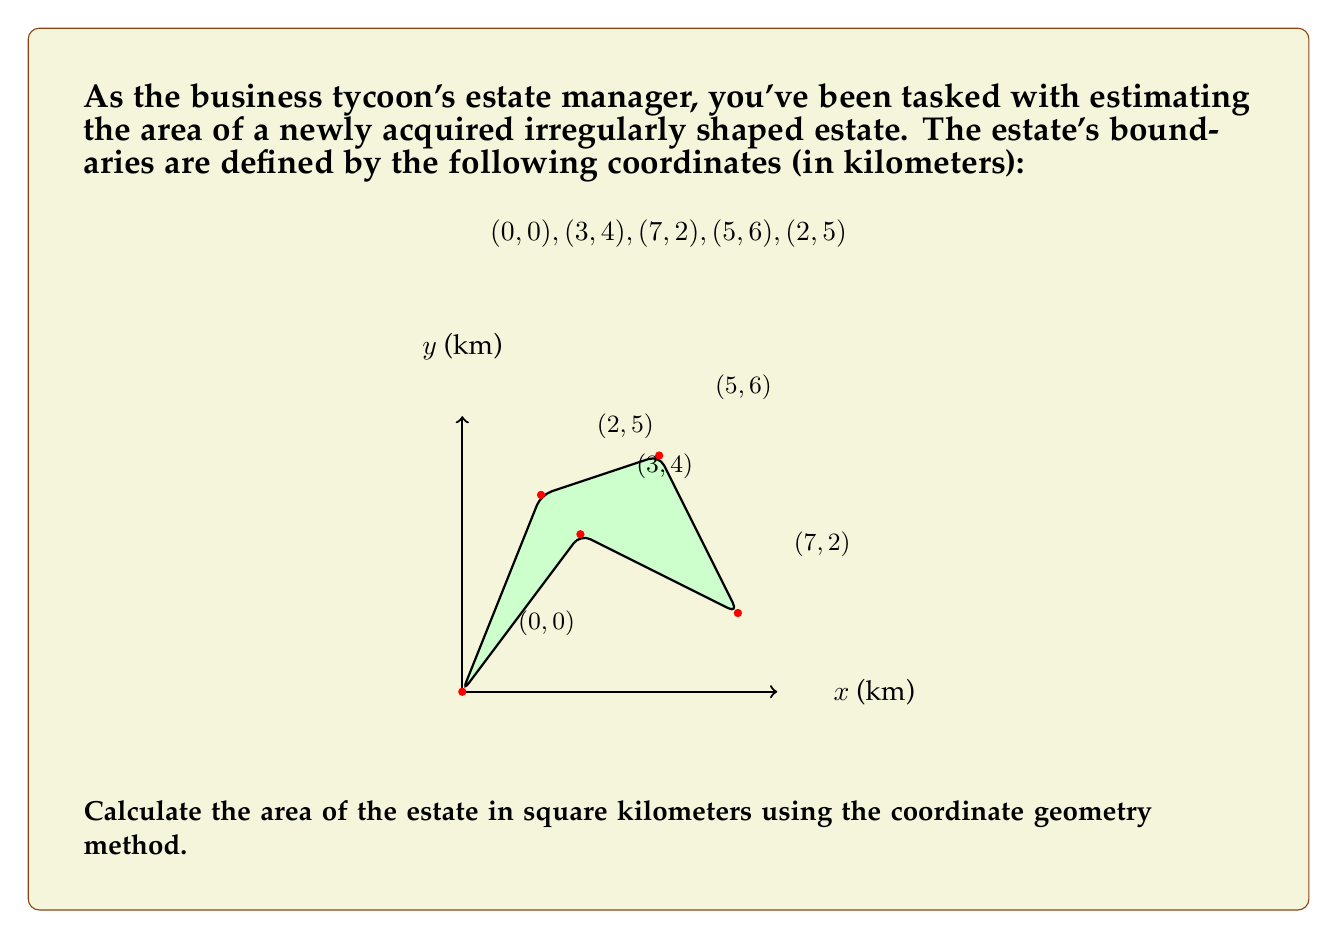Help me with this question. To calculate the area of this irregularly shaped estate, we can use the Shoelace formula (also known as the surveyor's formula). This method works for any polygon given its vertices.

The formula is:

$$A = \frac{1}{2}|\sum_{i=1}^{n-1} (x_i y_{i+1} + x_n y_1) - \sum_{i=1}^{n-1} (y_i x_{i+1} + y_n x_1)|$$

Where $(x_i, y_i)$ are the coordinates of the $i$-th vertex.

Let's apply this formula to our estate:

1) First, let's organize our points:
   $(x_1, y_1) = (0, 0)$
   $(x_2, y_2) = (3, 4)$
   $(x_3, y_3) = (7, 2)$
   $(x_4, y_4) = (5, 6)$
   $(x_5, y_5) = (2, 5)$

2) Now, let's calculate the first sum:
   $\sum_{i=1}^{n-1} (x_i y_{i+1} + x_n y_1)$
   $= (0 \cdot 4 + 3 \cdot 2 + 7 \cdot 6 + 5 \cdot 5 + 2 \cdot 0)$
   $= 0 + 6 + 42 + 25 + 0 = 73$

3) Next, calculate the second sum:
   $\sum_{i=1}^{n-1} (y_i x_{i+1} + y_n x_1)$
   $= (0 \cdot 3 + 4 \cdot 7 + 2 \cdot 5 + 6 \cdot 2 + 5 \cdot 0)$
   $= 0 + 28 + 10 + 12 + 0 = 50$

4) Subtract the second sum from the first:
   $73 - 50 = 23$

5) Take the absolute value and divide by 2:
   $\frac{1}{2}|23| = 11.5$

Therefore, the area of the estate is 11.5 square kilometers.
Answer: 11.5 km² 